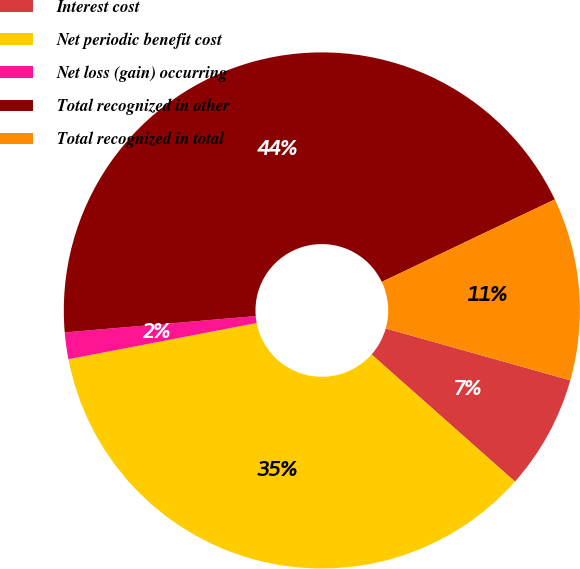<chart> <loc_0><loc_0><loc_500><loc_500><pie_chart><fcel>Interest cost<fcel>Net periodic benefit cost<fcel>Net loss (gain) occurring<fcel>Total recognized in other<fcel>Total recognized in total<nl><fcel>7.18%<fcel>35.43%<fcel>1.67%<fcel>44.28%<fcel>11.44%<nl></chart> 